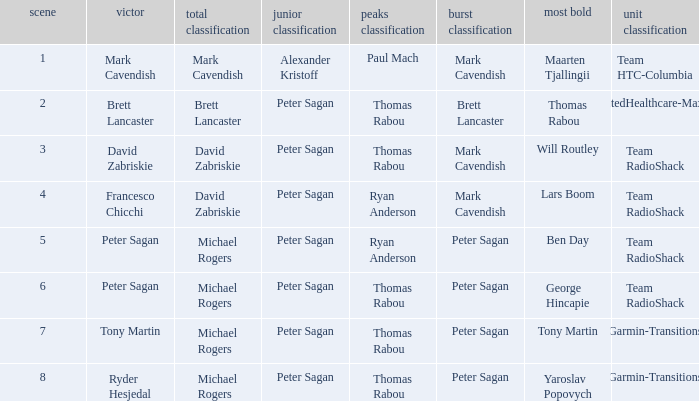Give me the full table as a dictionary. {'header': ['scene', 'victor', 'total classification', 'junior classification', 'peaks classification', 'burst classification', 'most bold', 'unit classification'], 'rows': [['1', 'Mark Cavendish', 'Mark Cavendish', 'Alexander Kristoff', 'Paul Mach', 'Mark Cavendish', 'Maarten Tjallingii', 'Team HTC-Columbia'], ['2', 'Brett Lancaster', 'Brett Lancaster', 'Peter Sagan', 'Thomas Rabou', 'Brett Lancaster', 'Thomas Rabou', 'UnitedHealthcare-Maxxis'], ['3', 'David Zabriskie', 'David Zabriskie', 'Peter Sagan', 'Thomas Rabou', 'Mark Cavendish', 'Will Routley', 'Team RadioShack'], ['4', 'Francesco Chicchi', 'David Zabriskie', 'Peter Sagan', 'Ryan Anderson', 'Mark Cavendish', 'Lars Boom', 'Team RadioShack'], ['5', 'Peter Sagan', 'Michael Rogers', 'Peter Sagan', 'Ryan Anderson', 'Peter Sagan', 'Ben Day', 'Team RadioShack'], ['6', 'Peter Sagan', 'Michael Rogers', 'Peter Sagan', 'Thomas Rabou', 'Peter Sagan', 'George Hincapie', 'Team RadioShack'], ['7', 'Tony Martin', 'Michael Rogers', 'Peter Sagan', 'Thomas Rabou', 'Peter Sagan', 'Tony Martin', 'Garmin-Transitions'], ['8', 'Ryder Hesjedal', 'Michael Rogers', 'Peter Sagan', 'Thomas Rabou', 'Peter Sagan', 'Yaroslav Popovych', 'Garmin-Transitions']]} When Ryan Anderson won the mountains classification, and Michael Rogers won the general classification, who won the sprint classification? Peter Sagan. 